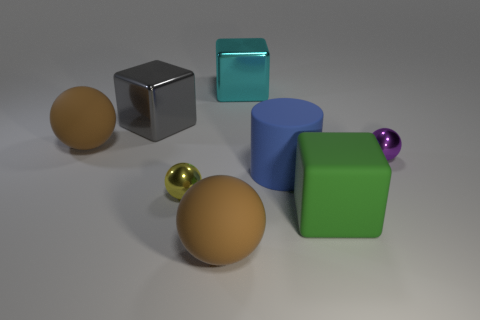Subtract all yellow balls. How many balls are left? 3 Subtract all gray balls. Subtract all blue cylinders. How many balls are left? 4 Add 1 big green cubes. How many objects exist? 9 Subtract all cylinders. How many objects are left? 7 Subtract all cyan shiny blocks. Subtract all red metal cylinders. How many objects are left? 7 Add 7 big green things. How many big green things are left? 8 Add 3 cyan matte cylinders. How many cyan matte cylinders exist? 3 Subtract 1 green cubes. How many objects are left? 7 